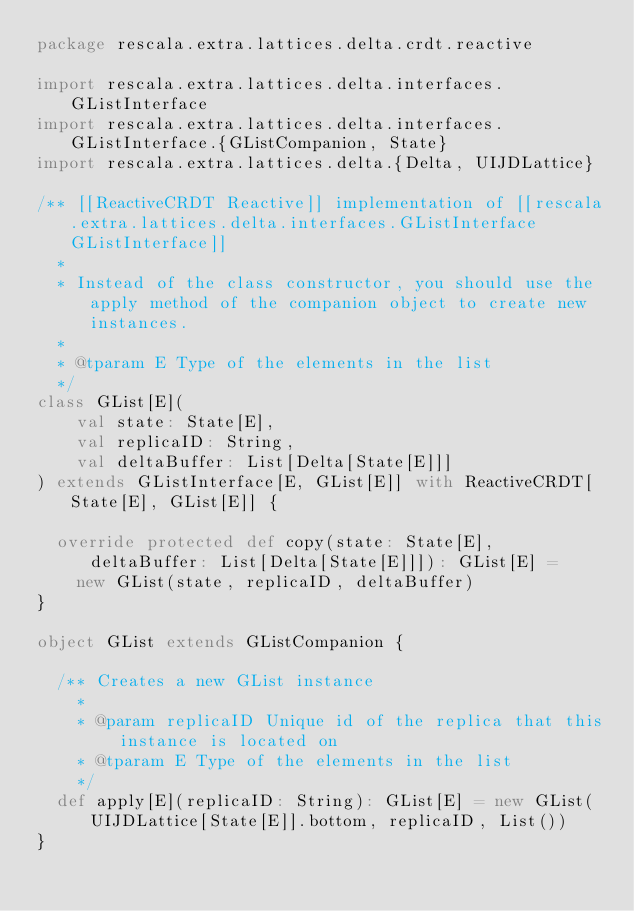<code> <loc_0><loc_0><loc_500><loc_500><_Scala_>package rescala.extra.lattices.delta.crdt.reactive

import rescala.extra.lattices.delta.interfaces.GListInterface
import rescala.extra.lattices.delta.interfaces.GListInterface.{GListCompanion, State}
import rescala.extra.lattices.delta.{Delta, UIJDLattice}

/** [[ReactiveCRDT Reactive]] implementation of [[rescala.extra.lattices.delta.interfaces.GListInterface GListInterface]]
  *
  * Instead of the class constructor, you should use the apply method of the companion object to create new instances.
  *
  * @tparam E Type of the elements in the list
  */
class GList[E](
    val state: State[E],
    val replicaID: String,
    val deltaBuffer: List[Delta[State[E]]]
) extends GListInterface[E, GList[E]] with ReactiveCRDT[State[E], GList[E]] {

  override protected def copy(state: State[E], deltaBuffer: List[Delta[State[E]]]): GList[E] =
    new GList(state, replicaID, deltaBuffer)
}

object GList extends GListCompanion {

  /** Creates a new GList instance
    *
    * @param replicaID Unique id of the replica that this instance is located on
    * @tparam E Type of the elements in the list
    */
  def apply[E](replicaID: String): GList[E] = new GList(UIJDLattice[State[E]].bottom, replicaID, List())
}
</code> 